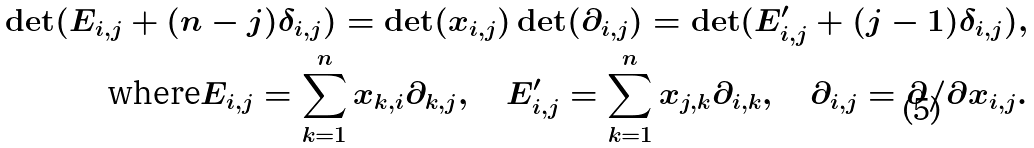Convert formula to latex. <formula><loc_0><loc_0><loc_500><loc_500>\det ( E _ { i , j } + ( n - j ) \delta _ { i , j } ) = \det ( x _ { i , j } ) \det ( \partial _ { i , j } ) = \det ( E ^ { \prime } _ { i , j } + ( j - 1 ) \delta _ { i , j } ) , \\ \text {where} E _ { i , j } = \sum _ { k = 1 } ^ { n } x _ { k , i } \partial _ { k , j } , \quad E ^ { \prime } _ { i , j } = \sum _ { k = 1 } ^ { n } x _ { j , k } \partial _ { i , k } , \quad \partial _ { i , j } = \partial / \partial x _ { i , j } .</formula> 